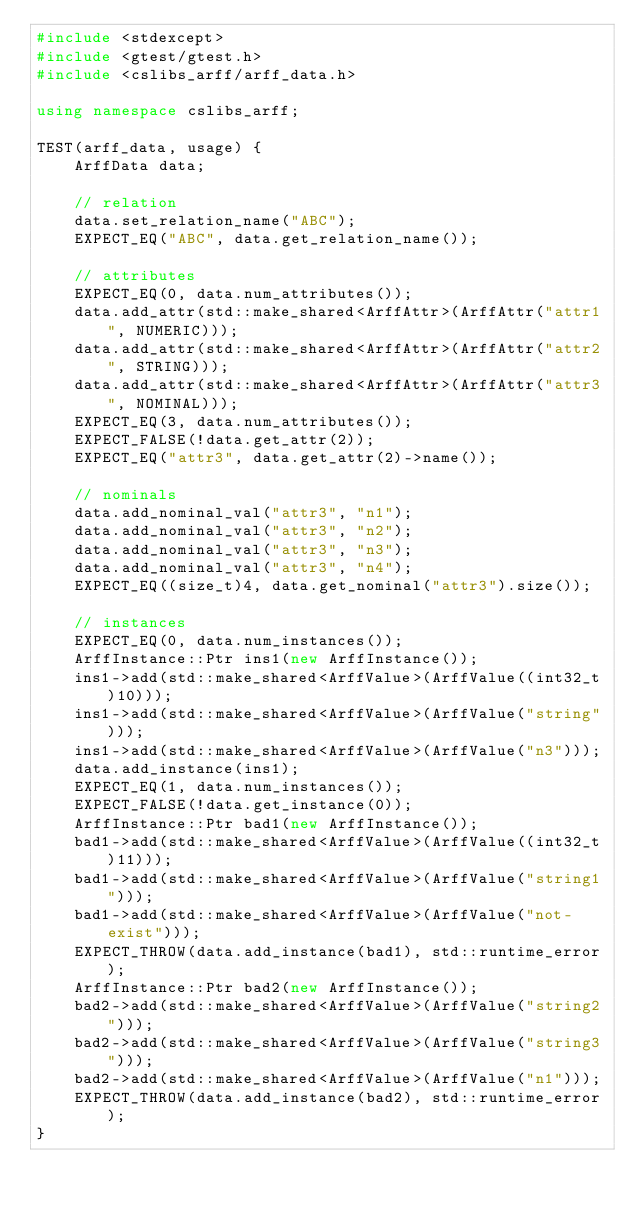<code> <loc_0><loc_0><loc_500><loc_500><_C++_>#include <stdexcept>
#include <gtest/gtest.h>
#include <cslibs_arff/arff_data.h>

using namespace cslibs_arff;

TEST(arff_data, usage) {
    ArffData data;

    // relation
    data.set_relation_name("ABC");
    EXPECT_EQ("ABC", data.get_relation_name());

    // attributes
    EXPECT_EQ(0, data.num_attributes());
    data.add_attr(std::make_shared<ArffAttr>(ArffAttr("attr1", NUMERIC)));
    data.add_attr(std::make_shared<ArffAttr>(ArffAttr("attr2", STRING)));
    data.add_attr(std::make_shared<ArffAttr>(ArffAttr("attr3", NOMINAL)));
    EXPECT_EQ(3, data.num_attributes());
    EXPECT_FALSE(!data.get_attr(2));
    EXPECT_EQ("attr3", data.get_attr(2)->name());

    // nominals
    data.add_nominal_val("attr3", "n1");
    data.add_nominal_val("attr3", "n2");
    data.add_nominal_val("attr3", "n3");
    data.add_nominal_val("attr3", "n4");
    EXPECT_EQ((size_t)4, data.get_nominal("attr3").size());

    // instances
    EXPECT_EQ(0, data.num_instances());
    ArffInstance::Ptr ins1(new ArffInstance());
    ins1->add(std::make_shared<ArffValue>(ArffValue((int32_t)10)));
    ins1->add(std::make_shared<ArffValue>(ArffValue("string")));
    ins1->add(std::make_shared<ArffValue>(ArffValue("n3")));
    data.add_instance(ins1);
    EXPECT_EQ(1, data.num_instances());
    EXPECT_FALSE(!data.get_instance(0));
    ArffInstance::Ptr bad1(new ArffInstance());
    bad1->add(std::make_shared<ArffValue>(ArffValue((int32_t)11)));
    bad1->add(std::make_shared<ArffValue>(ArffValue("string1")));
    bad1->add(std::make_shared<ArffValue>(ArffValue("not-exist")));
    EXPECT_THROW(data.add_instance(bad1), std::runtime_error);
    ArffInstance::Ptr bad2(new ArffInstance());
    bad2->add(std::make_shared<ArffValue>(ArffValue("string2")));
    bad2->add(std::make_shared<ArffValue>(ArffValue("string3")));
    bad2->add(std::make_shared<ArffValue>(ArffValue("n1")));
    EXPECT_THROW(data.add_instance(bad2), std::runtime_error);
}
</code> 